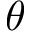Convert formula to latex. <formula><loc_0><loc_0><loc_500><loc_500>\theta</formula> 